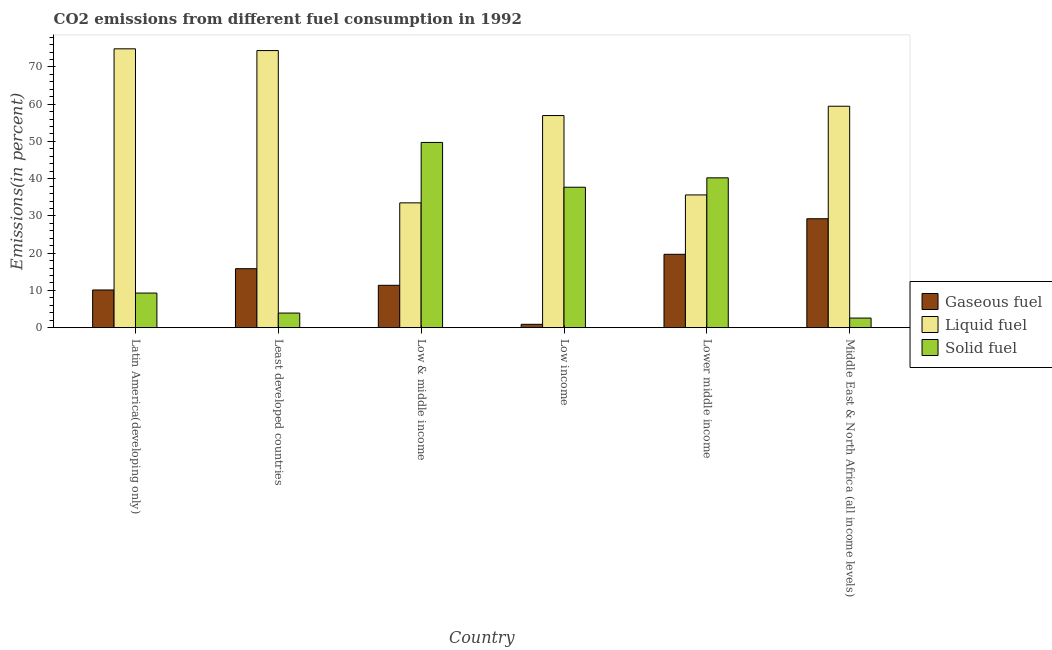Are the number of bars per tick equal to the number of legend labels?
Make the answer very short. Yes. How many bars are there on the 6th tick from the right?
Your answer should be very brief. 3. In how many cases, is the number of bars for a given country not equal to the number of legend labels?
Your answer should be very brief. 0. What is the percentage of gaseous fuel emission in Low & middle income?
Your answer should be compact. 11.37. Across all countries, what is the maximum percentage of liquid fuel emission?
Your response must be concise. 74.87. Across all countries, what is the minimum percentage of solid fuel emission?
Give a very brief answer. 2.57. In which country was the percentage of solid fuel emission minimum?
Provide a succinct answer. Middle East & North Africa (all income levels). What is the total percentage of liquid fuel emission in the graph?
Your answer should be compact. 334.81. What is the difference between the percentage of solid fuel emission in Low income and that in Middle East & North Africa (all income levels)?
Provide a short and direct response. 35.13. What is the difference between the percentage of liquid fuel emission in Lower middle income and the percentage of solid fuel emission in Least developed countries?
Offer a very short reply. 31.71. What is the average percentage of liquid fuel emission per country?
Provide a short and direct response. 55.8. What is the difference between the percentage of liquid fuel emission and percentage of gaseous fuel emission in Latin America(developing only)?
Offer a terse response. 64.75. What is the ratio of the percentage of gaseous fuel emission in Least developed countries to that in Low & middle income?
Provide a short and direct response. 1.39. Is the percentage of gaseous fuel emission in Low & middle income less than that in Middle East & North Africa (all income levels)?
Ensure brevity in your answer.  Yes. What is the difference between the highest and the second highest percentage of solid fuel emission?
Give a very brief answer. 9.5. What is the difference between the highest and the lowest percentage of gaseous fuel emission?
Your answer should be very brief. 28.34. What does the 2nd bar from the left in Low & middle income represents?
Make the answer very short. Liquid fuel. What does the 1st bar from the right in Low income represents?
Give a very brief answer. Solid fuel. Is it the case that in every country, the sum of the percentage of gaseous fuel emission and percentage of liquid fuel emission is greater than the percentage of solid fuel emission?
Offer a very short reply. No. How many bars are there?
Provide a succinct answer. 18. Are all the bars in the graph horizontal?
Keep it short and to the point. No. How many countries are there in the graph?
Provide a short and direct response. 6. Are the values on the major ticks of Y-axis written in scientific E-notation?
Ensure brevity in your answer.  No. Does the graph contain any zero values?
Make the answer very short. No. Does the graph contain grids?
Provide a succinct answer. No. Where does the legend appear in the graph?
Provide a short and direct response. Center right. How many legend labels are there?
Give a very brief answer. 3. What is the title of the graph?
Give a very brief answer. CO2 emissions from different fuel consumption in 1992. Does "Self-employed" appear as one of the legend labels in the graph?
Provide a short and direct response. No. What is the label or title of the Y-axis?
Your answer should be very brief. Emissions(in percent). What is the Emissions(in percent) of Gaseous fuel in Latin America(developing only)?
Your response must be concise. 10.12. What is the Emissions(in percent) in Liquid fuel in Latin America(developing only)?
Ensure brevity in your answer.  74.87. What is the Emissions(in percent) of Solid fuel in Latin America(developing only)?
Your response must be concise. 9.29. What is the Emissions(in percent) of Gaseous fuel in Least developed countries?
Provide a short and direct response. 15.83. What is the Emissions(in percent) of Liquid fuel in Least developed countries?
Give a very brief answer. 74.39. What is the Emissions(in percent) of Solid fuel in Least developed countries?
Offer a very short reply. 3.92. What is the Emissions(in percent) in Gaseous fuel in Low & middle income?
Keep it short and to the point. 11.37. What is the Emissions(in percent) in Liquid fuel in Low & middle income?
Keep it short and to the point. 33.51. What is the Emissions(in percent) in Solid fuel in Low & middle income?
Your response must be concise. 49.73. What is the Emissions(in percent) in Gaseous fuel in Low income?
Offer a terse response. 0.9. What is the Emissions(in percent) of Liquid fuel in Low income?
Your response must be concise. 56.95. What is the Emissions(in percent) in Solid fuel in Low income?
Your response must be concise. 37.7. What is the Emissions(in percent) of Gaseous fuel in Lower middle income?
Make the answer very short. 19.7. What is the Emissions(in percent) in Liquid fuel in Lower middle income?
Offer a terse response. 35.64. What is the Emissions(in percent) of Solid fuel in Lower middle income?
Your answer should be compact. 40.23. What is the Emissions(in percent) of Gaseous fuel in Middle East & North Africa (all income levels)?
Your answer should be very brief. 29.24. What is the Emissions(in percent) in Liquid fuel in Middle East & North Africa (all income levels)?
Your response must be concise. 59.45. What is the Emissions(in percent) in Solid fuel in Middle East & North Africa (all income levels)?
Ensure brevity in your answer.  2.57. Across all countries, what is the maximum Emissions(in percent) in Gaseous fuel?
Provide a succinct answer. 29.24. Across all countries, what is the maximum Emissions(in percent) of Liquid fuel?
Make the answer very short. 74.87. Across all countries, what is the maximum Emissions(in percent) in Solid fuel?
Ensure brevity in your answer.  49.73. Across all countries, what is the minimum Emissions(in percent) in Gaseous fuel?
Give a very brief answer. 0.9. Across all countries, what is the minimum Emissions(in percent) of Liquid fuel?
Your response must be concise. 33.51. Across all countries, what is the minimum Emissions(in percent) of Solid fuel?
Provide a succinct answer. 2.57. What is the total Emissions(in percent) in Gaseous fuel in the graph?
Ensure brevity in your answer.  87.16. What is the total Emissions(in percent) of Liquid fuel in the graph?
Your answer should be compact. 334.81. What is the total Emissions(in percent) in Solid fuel in the graph?
Offer a terse response. 143.45. What is the difference between the Emissions(in percent) in Gaseous fuel in Latin America(developing only) and that in Least developed countries?
Provide a succinct answer. -5.71. What is the difference between the Emissions(in percent) of Liquid fuel in Latin America(developing only) and that in Least developed countries?
Keep it short and to the point. 0.47. What is the difference between the Emissions(in percent) in Solid fuel in Latin America(developing only) and that in Least developed countries?
Your answer should be compact. 5.37. What is the difference between the Emissions(in percent) of Gaseous fuel in Latin America(developing only) and that in Low & middle income?
Offer a very short reply. -1.26. What is the difference between the Emissions(in percent) in Liquid fuel in Latin America(developing only) and that in Low & middle income?
Offer a terse response. 41.36. What is the difference between the Emissions(in percent) of Solid fuel in Latin America(developing only) and that in Low & middle income?
Give a very brief answer. -40.44. What is the difference between the Emissions(in percent) in Gaseous fuel in Latin America(developing only) and that in Low income?
Make the answer very short. 9.22. What is the difference between the Emissions(in percent) in Liquid fuel in Latin America(developing only) and that in Low income?
Your response must be concise. 17.92. What is the difference between the Emissions(in percent) in Solid fuel in Latin America(developing only) and that in Low income?
Offer a very short reply. -28.41. What is the difference between the Emissions(in percent) of Gaseous fuel in Latin America(developing only) and that in Lower middle income?
Your answer should be very brief. -9.58. What is the difference between the Emissions(in percent) of Liquid fuel in Latin America(developing only) and that in Lower middle income?
Ensure brevity in your answer.  39.23. What is the difference between the Emissions(in percent) in Solid fuel in Latin America(developing only) and that in Lower middle income?
Keep it short and to the point. -30.93. What is the difference between the Emissions(in percent) in Gaseous fuel in Latin America(developing only) and that in Middle East & North Africa (all income levels)?
Keep it short and to the point. -19.12. What is the difference between the Emissions(in percent) of Liquid fuel in Latin America(developing only) and that in Middle East & North Africa (all income levels)?
Provide a succinct answer. 15.41. What is the difference between the Emissions(in percent) in Solid fuel in Latin America(developing only) and that in Middle East & North Africa (all income levels)?
Ensure brevity in your answer.  6.72. What is the difference between the Emissions(in percent) in Gaseous fuel in Least developed countries and that in Low & middle income?
Keep it short and to the point. 4.46. What is the difference between the Emissions(in percent) in Liquid fuel in Least developed countries and that in Low & middle income?
Make the answer very short. 40.88. What is the difference between the Emissions(in percent) of Solid fuel in Least developed countries and that in Low & middle income?
Your answer should be compact. -45.81. What is the difference between the Emissions(in percent) in Gaseous fuel in Least developed countries and that in Low income?
Provide a short and direct response. 14.93. What is the difference between the Emissions(in percent) in Liquid fuel in Least developed countries and that in Low income?
Offer a very short reply. 17.45. What is the difference between the Emissions(in percent) in Solid fuel in Least developed countries and that in Low income?
Your answer should be very brief. -33.78. What is the difference between the Emissions(in percent) of Gaseous fuel in Least developed countries and that in Lower middle income?
Ensure brevity in your answer.  -3.87. What is the difference between the Emissions(in percent) of Liquid fuel in Least developed countries and that in Lower middle income?
Make the answer very short. 38.76. What is the difference between the Emissions(in percent) in Solid fuel in Least developed countries and that in Lower middle income?
Offer a terse response. -36.3. What is the difference between the Emissions(in percent) of Gaseous fuel in Least developed countries and that in Middle East & North Africa (all income levels)?
Offer a terse response. -13.41. What is the difference between the Emissions(in percent) in Liquid fuel in Least developed countries and that in Middle East & North Africa (all income levels)?
Ensure brevity in your answer.  14.94. What is the difference between the Emissions(in percent) of Solid fuel in Least developed countries and that in Middle East & North Africa (all income levels)?
Your answer should be very brief. 1.35. What is the difference between the Emissions(in percent) of Gaseous fuel in Low & middle income and that in Low income?
Your answer should be compact. 10.48. What is the difference between the Emissions(in percent) in Liquid fuel in Low & middle income and that in Low income?
Provide a short and direct response. -23.44. What is the difference between the Emissions(in percent) of Solid fuel in Low & middle income and that in Low income?
Provide a succinct answer. 12.03. What is the difference between the Emissions(in percent) of Gaseous fuel in Low & middle income and that in Lower middle income?
Ensure brevity in your answer.  -8.32. What is the difference between the Emissions(in percent) in Liquid fuel in Low & middle income and that in Lower middle income?
Your response must be concise. -2.13. What is the difference between the Emissions(in percent) in Solid fuel in Low & middle income and that in Lower middle income?
Provide a short and direct response. 9.5. What is the difference between the Emissions(in percent) in Gaseous fuel in Low & middle income and that in Middle East & North Africa (all income levels)?
Provide a short and direct response. -17.87. What is the difference between the Emissions(in percent) of Liquid fuel in Low & middle income and that in Middle East & North Africa (all income levels)?
Provide a succinct answer. -25.94. What is the difference between the Emissions(in percent) in Solid fuel in Low & middle income and that in Middle East & North Africa (all income levels)?
Make the answer very short. 47.15. What is the difference between the Emissions(in percent) of Gaseous fuel in Low income and that in Lower middle income?
Make the answer very short. -18.8. What is the difference between the Emissions(in percent) of Liquid fuel in Low income and that in Lower middle income?
Ensure brevity in your answer.  21.31. What is the difference between the Emissions(in percent) in Solid fuel in Low income and that in Lower middle income?
Your answer should be compact. -2.52. What is the difference between the Emissions(in percent) of Gaseous fuel in Low income and that in Middle East & North Africa (all income levels)?
Keep it short and to the point. -28.34. What is the difference between the Emissions(in percent) in Liquid fuel in Low income and that in Middle East & North Africa (all income levels)?
Offer a terse response. -2.51. What is the difference between the Emissions(in percent) of Solid fuel in Low income and that in Middle East & North Africa (all income levels)?
Give a very brief answer. 35.13. What is the difference between the Emissions(in percent) of Gaseous fuel in Lower middle income and that in Middle East & North Africa (all income levels)?
Make the answer very short. -9.54. What is the difference between the Emissions(in percent) of Liquid fuel in Lower middle income and that in Middle East & North Africa (all income levels)?
Provide a short and direct response. -23.82. What is the difference between the Emissions(in percent) of Solid fuel in Lower middle income and that in Middle East & North Africa (all income levels)?
Make the answer very short. 37.65. What is the difference between the Emissions(in percent) of Gaseous fuel in Latin America(developing only) and the Emissions(in percent) of Liquid fuel in Least developed countries?
Keep it short and to the point. -64.28. What is the difference between the Emissions(in percent) of Gaseous fuel in Latin America(developing only) and the Emissions(in percent) of Solid fuel in Least developed countries?
Provide a succinct answer. 6.19. What is the difference between the Emissions(in percent) in Liquid fuel in Latin America(developing only) and the Emissions(in percent) in Solid fuel in Least developed countries?
Your answer should be very brief. 70.94. What is the difference between the Emissions(in percent) in Gaseous fuel in Latin America(developing only) and the Emissions(in percent) in Liquid fuel in Low & middle income?
Ensure brevity in your answer.  -23.39. What is the difference between the Emissions(in percent) in Gaseous fuel in Latin America(developing only) and the Emissions(in percent) in Solid fuel in Low & middle income?
Your response must be concise. -39.61. What is the difference between the Emissions(in percent) of Liquid fuel in Latin America(developing only) and the Emissions(in percent) of Solid fuel in Low & middle income?
Provide a succinct answer. 25.14. What is the difference between the Emissions(in percent) in Gaseous fuel in Latin America(developing only) and the Emissions(in percent) in Liquid fuel in Low income?
Provide a short and direct response. -46.83. What is the difference between the Emissions(in percent) in Gaseous fuel in Latin America(developing only) and the Emissions(in percent) in Solid fuel in Low income?
Provide a short and direct response. -27.59. What is the difference between the Emissions(in percent) of Liquid fuel in Latin America(developing only) and the Emissions(in percent) of Solid fuel in Low income?
Give a very brief answer. 37.16. What is the difference between the Emissions(in percent) in Gaseous fuel in Latin America(developing only) and the Emissions(in percent) in Liquid fuel in Lower middle income?
Ensure brevity in your answer.  -25.52. What is the difference between the Emissions(in percent) of Gaseous fuel in Latin America(developing only) and the Emissions(in percent) of Solid fuel in Lower middle income?
Make the answer very short. -30.11. What is the difference between the Emissions(in percent) of Liquid fuel in Latin America(developing only) and the Emissions(in percent) of Solid fuel in Lower middle income?
Your answer should be very brief. 34.64. What is the difference between the Emissions(in percent) in Gaseous fuel in Latin America(developing only) and the Emissions(in percent) in Liquid fuel in Middle East & North Africa (all income levels)?
Ensure brevity in your answer.  -49.34. What is the difference between the Emissions(in percent) of Gaseous fuel in Latin America(developing only) and the Emissions(in percent) of Solid fuel in Middle East & North Africa (all income levels)?
Keep it short and to the point. 7.54. What is the difference between the Emissions(in percent) in Liquid fuel in Latin America(developing only) and the Emissions(in percent) in Solid fuel in Middle East & North Africa (all income levels)?
Your answer should be very brief. 72.29. What is the difference between the Emissions(in percent) of Gaseous fuel in Least developed countries and the Emissions(in percent) of Liquid fuel in Low & middle income?
Your answer should be compact. -17.68. What is the difference between the Emissions(in percent) in Gaseous fuel in Least developed countries and the Emissions(in percent) in Solid fuel in Low & middle income?
Your response must be concise. -33.9. What is the difference between the Emissions(in percent) of Liquid fuel in Least developed countries and the Emissions(in percent) of Solid fuel in Low & middle income?
Provide a short and direct response. 24.66. What is the difference between the Emissions(in percent) in Gaseous fuel in Least developed countries and the Emissions(in percent) in Liquid fuel in Low income?
Give a very brief answer. -41.12. What is the difference between the Emissions(in percent) of Gaseous fuel in Least developed countries and the Emissions(in percent) of Solid fuel in Low income?
Your response must be concise. -21.87. What is the difference between the Emissions(in percent) in Liquid fuel in Least developed countries and the Emissions(in percent) in Solid fuel in Low income?
Provide a short and direct response. 36.69. What is the difference between the Emissions(in percent) of Gaseous fuel in Least developed countries and the Emissions(in percent) of Liquid fuel in Lower middle income?
Your answer should be very brief. -19.81. What is the difference between the Emissions(in percent) in Gaseous fuel in Least developed countries and the Emissions(in percent) in Solid fuel in Lower middle income?
Keep it short and to the point. -24.39. What is the difference between the Emissions(in percent) of Liquid fuel in Least developed countries and the Emissions(in percent) of Solid fuel in Lower middle income?
Keep it short and to the point. 34.17. What is the difference between the Emissions(in percent) of Gaseous fuel in Least developed countries and the Emissions(in percent) of Liquid fuel in Middle East & North Africa (all income levels)?
Ensure brevity in your answer.  -43.62. What is the difference between the Emissions(in percent) of Gaseous fuel in Least developed countries and the Emissions(in percent) of Solid fuel in Middle East & North Africa (all income levels)?
Offer a terse response. 13.26. What is the difference between the Emissions(in percent) of Liquid fuel in Least developed countries and the Emissions(in percent) of Solid fuel in Middle East & North Africa (all income levels)?
Provide a short and direct response. 71.82. What is the difference between the Emissions(in percent) of Gaseous fuel in Low & middle income and the Emissions(in percent) of Liquid fuel in Low income?
Your answer should be compact. -45.57. What is the difference between the Emissions(in percent) in Gaseous fuel in Low & middle income and the Emissions(in percent) in Solid fuel in Low income?
Offer a very short reply. -26.33. What is the difference between the Emissions(in percent) of Liquid fuel in Low & middle income and the Emissions(in percent) of Solid fuel in Low income?
Offer a very short reply. -4.19. What is the difference between the Emissions(in percent) in Gaseous fuel in Low & middle income and the Emissions(in percent) in Liquid fuel in Lower middle income?
Give a very brief answer. -24.26. What is the difference between the Emissions(in percent) in Gaseous fuel in Low & middle income and the Emissions(in percent) in Solid fuel in Lower middle income?
Offer a very short reply. -28.85. What is the difference between the Emissions(in percent) of Liquid fuel in Low & middle income and the Emissions(in percent) of Solid fuel in Lower middle income?
Keep it short and to the point. -6.71. What is the difference between the Emissions(in percent) in Gaseous fuel in Low & middle income and the Emissions(in percent) in Liquid fuel in Middle East & North Africa (all income levels)?
Your response must be concise. -48.08. What is the difference between the Emissions(in percent) in Gaseous fuel in Low & middle income and the Emissions(in percent) in Solid fuel in Middle East & North Africa (all income levels)?
Your answer should be compact. 8.8. What is the difference between the Emissions(in percent) of Liquid fuel in Low & middle income and the Emissions(in percent) of Solid fuel in Middle East & North Africa (all income levels)?
Your answer should be very brief. 30.94. What is the difference between the Emissions(in percent) in Gaseous fuel in Low income and the Emissions(in percent) in Liquid fuel in Lower middle income?
Offer a very short reply. -34.74. What is the difference between the Emissions(in percent) of Gaseous fuel in Low income and the Emissions(in percent) of Solid fuel in Lower middle income?
Offer a terse response. -39.33. What is the difference between the Emissions(in percent) in Liquid fuel in Low income and the Emissions(in percent) in Solid fuel in Lower middle income?
Give a very brief answer. 16.72. What is the difference between the Emissions(in percent) in Gaseous fuel in Low income and the Emissions(in percent) in Liquid fuel in Middle East & North Africa (all income levels)?
Provide a short and direct response. -58.56. What is the difference between the Emissions(in percent) in Gaseous fuel in Low income and the Emissions(in percent) in Solid fuel in Middle East & North Africa (all income levels)?
Provide a short and direct response. -1.68. What is the difference between the Emissions(in percent) of Liquid fuel in Low income and the Emissions(in percent) of Solid fuel in Middle East & North Africa (all income levels)?
Offer a terse response. 54.37. What is the difference between the Emissions(in percent) of Gaseous fuel in Lower middle income and the Emissions(in percent) of Liquid fuel in Middle East & North Africa (all income levels)?
Provide a short and direct response. -39.76. What is the difference between the Emissions(in percent) of Gaseous fuel in Lower middle income and the Emissions(in percent) of Solid fuel in Middle East & North Africa (all income levels)?
Make the answer very short. 17.12. What is the difference between the Emissions(in percent) in Liquid fuel in Lower middle income and the Emissions(in percent) in Solid fuel in Middle East & North Africa (all income levels)?
Keep it short and to the point. 33.06. What is the average Emissions(in percent) in Gaseous fuel per country?
Keep it short and to the point. 14.53. What is the average Emissions(in percent) of Liquid fuel per country?
Make the answer very short. 55.8. What is the average Emissions(in percent) of Solid fuel per country?
Give a very brief answer. 23.91. What is the difference between the Emissions(in percent) in Gaseous fuel and Emissions(in percent) in Liquid fuel in Latin America(developing only)?
Provide a succinct answer. -64.75. What is the difference between the Emissions(in percent) in Gaseous fuel and Emissions(in percent) in Solid fuel in Latin America(developing only)?
Give a very brief answer. 0.83. What is the difference between the Emissions(in percent) of Liquid fuel and Emissions(in percent) of Solid fuel in Latin America(developing only)?
Your answer should be very brief. 65.58. What is the difference between the Emissions(in percent) in Gaseous fuel and Emissions(in percent) in Liquid fuel in Least developed countries?
Ensure brevity in your answer.  -58.56. What is the difference between the Emissions(in percent) of Gaseous fuel and Emissions(in percent) of Solid fuel in Least developed countries?
Offer a very short reply. 11.91. What is the difference between the Emissions(in percent) of Liquid fuel and Emissions(in percent) of Solid fuel in Least developed countries?
Keep it short and to the point. 70.47. What is the difference between the Emissions(in percent) in Gaseous fuel and Emissions(in percent) in Liquid fuel in Low & middle income?
Provide a short and direct response. -22.14. What is the difference between the Emissions(in percent) in Gaseous fuel and Emissions(in percent) in Solid fuel in Low & middle income?
Offer a very short reply. -38.36. What is the difference between the Emissions(in percent) in Liquid fuel and Emissions(in percent) in Solid fuel in Low & middle income?
Offer a very short reply. -16.22. What is the difference between the Emissions(in percent) of Gaseous fuel and Emissions(in percent) of Liquid fuel in Low income?
Make the answer very short. -56.05. What is the difference between the Emissions(in percent) in Gaseous fuel and Emissions(in percent) in Solid fuel in Low income?
Keep it short and to the point. -36.81. What is the difference between the Emissions(in percent) in Liquid fuel and Emissions(in percent) in Solid fuel in Low income?
Provide a succinct answer. 19.24. What is the difference between the Emissions(in percent) of Gaseous fuel and Emissions(in percent) of Liquid fuel in Lower middle income?
Your answer should be compact. -15.94. What is the difference between the Emissions(in percent) in Gaseous fuel and Emissions(in percent) in Solid fuel in Lower middle income?
Provide a succinct answer. -20.53. What is the difference between the Emissions(in percent) of Liquid fuel and Emissions(in percent) of Solid fuel in Lower middle income?
Provide a short and direct response. -4.59. What is the difference between the Emissions(in percent) of Gaseous fuel and Emissions(in percent) of Liquid fuel in Middle East & North Africa (all income levels)?
Offer a very short reply. -30.21. What is the difference between the Emissions(in percent) in Gaseous fuel and Emissions(in percent) in Solid fuel in Middle East & North Africa (all income levels)?
Ensure brevity in your answer.  26.67. What is the difference between the Emissions(in percent) in Liquid fuel and Emissions(in percent) in Solid fuel in Middle East & North Africa (all income levels)?
Your response must be concise. 56.88. What is the ratio of the Emissions(in percent) in Gaseous fuel in Latin America(developing only) to that in Least developed countries?
Keep it short and to the point. 0.64. What is the ratio of the Emissions(in percent) in Solid fuel in Latin America(developing only) to that in Least developed countries?
Give a very brief answer. 2.37. What is the ratio of the Emissions(in percent) of Gaseous fuel in Latin America(developing only) to that in Low & middle income?
Keep it short and to the point. 0.89. What is the ratio of the Emissions(in percent) in Liquid fuel in Latin America(developing only) to that in Low & middle income?
Your response must be concise. 2.23. What is the ratio of the Emissions(in percent) in Solid fuel in Latin America(developing only) to that in Low & middle income?
Your response must be concise. 0.19. What is the ratio of the Emissions(in percent) in Gaseous fuel in Latin America(developing only) to that in Low income?
Provide a short and direct response. 11.27. What is the ratio of the Emissions(in percent) of Liquid fuel in Latin America(developing only) to that in Low income?
Your response must be concise. 1.31. What is the ratio of the Emissions(in percent) in Solid fuel in Latin America(developing only) to that in Low income?
Offer a very short reply. 0.25. What is the ratio of the Emissions(in percent) in Gaseous fuel in Latin America(developing only) to that in Lower middle income?
Offer a very short reply. 0.51. What is the ratio of the Emissions(in percent) of Liquid fuel in Latin America(developing only) to that in Lower middle income?
Make the answer very short. 2.1. What is the ratio of the Emissions(in percent) of Solid fuel in Latin America(developing only) to that in Lower middle income?
Your answer should be very brief. 0.23. What is the ratio of the Emissions(in percent) of Gaseous fuel in Latin America(developing only) to that in Middle East & North Africa (all income levels)?
Offer a terse response. 0.35. What is the ratio of the Emissions(in percent) of Liquid fuel in Latin America(developing only) to that in Middle East & North Africa (all income levels)?
Keep it short and to the point. 1.26. What is the ratio of the Emissions(in percent) in Solid fuel in Latin America(developing only) to that in Middle East & North Africa (all income levels)?
Your answer should be compact. 3.61. What is the ratio of the Emissions(in percent) in Gaseous fuel in Least developed countries to that in Low & middle income?
Ensure brevity in your answer.  1.39. What is the ratio of the Emissions(in percent) in Liquid fuel in Least developed countries to that in Low & middle income?
Provide a short and direct response. 2.22. What is the ratio of the Emissions(in percent) in Solid fuel in Least developed countries to that in Low & middle income?
Your answer should be very brief. 0.08. What is the ratio of the Emissions(in percent) in Gaseous fuel in Least developed countries to that in Low income?
Your answer should be compact. 17.63. What is the ratio of the Emissions(in percent) in Liquid fuel in Least developed countries to that in Low income?
Offer a terse response. 1.31. What is the ratio of the Emissions(in percent) of Solid fuel in Least developed countries to that in Low income?
Offer a terse response. 0.1. What is the ratio of the Emissions(in percent) in Gaseous fuel in Least developed countries to that in Lower middle income?
Your answer should be very brief. 0.8. What is the ratio of the Emissions(in percent) of Liquid fuel in Least developed countries to that in Lower middle income?
Keep it short and to the point. 2.09. What is the ratio of the Emissions(in percent) in Solid fuel in Least developed countries to that in Lower middle income?
Your answer should be very brief. 0.1. What is the ratio of the Emissions(in percent) in Gaseous fuel in Least developed countries to that in Middle East & North Africa (all income levels)?
Give a very brief answer. 0.54. What is the ratio of the Emissions(in percent) of Liquid fuel in Least developed countries to that in Middle East & North Africa (all income levels)?
Offer a very short reply. 1.25. What is the ratio of the Emissions(in percent) of Solid fuel in Least developed countries to that in Middle East & North Africa (all income levels)?
Provide a short and direct response. 1.52. What is the ratio of the Emissions(in percent) of Gaseous fuel in Low & middle income to that in Low income?
Keep it short and to the point. 12.67. What is the ratio of the Emissions(in percent) in Liquid fuel in Low & middle income to that in Low income?
Keep it short and to the point. 0.59. What is the ratio of the Emissions(in percent) of Solid fuel in Low & middle income to that in Low income?
Keep it short and to the point. 1.32. What is the ratio of the Emissions(in percent) in Gaseous fuel in Low & middle income to that in Lower middle income?
Your answer should be compact. 0.58. What is the ratio of the Emissions(in percent) in Liquid fuel in Low & middle income to that in Lower middle income?
Keep it short and to the point. 0.94. What is the ratio of the Emissions(in percent) in Solid fuel in Low & middle income to that in Lower middle income?
Offer a very short reply. 1.24. What is the ratio of the Emissions(in percent) in Gaseous fuel in Low & middle income to that in Middle East & North Africa (all income levels)?
Your answer should be compact. 0.39. What is the ratio of the Emissions(in percent) of Liquid fuel in Low & middle income to that in Middle East & North Africa (all income levels)?
Your answer should be compact. 0.56. What is the ratio of the Emissions(in percent) in Solid fuel in Low & middle income to that in Middle East & North Africa (all income levels)?
Your answer should be compact. 19.32. What is the ratio of the Emissions(in percent) in Gaseous fuel in Low income to that in Lower middle income?
Your response must be concise. 0.05. What is the ratio of the Emissions(in percent) in Liquid fuel in Low income to that in Lower middle income?
Offer a terse response. 1.6. What is the ratio of the Emissions(in percent) in Solid fuel in Low income to that in Lower middle income?
Offer a terse response. 0.94. What is the ratio of the Emissions(in percent) in Gaseous fuel in Low income to that in Middle East & North Africa (all income levels)?
Your answer should be compact. 0.03. What is the ratio of the Emissions(in percent) of Liquid fuel in Low income to that in Middle East & North Africa (all income levels)?
Ensure brevity in your answer.  0.96. What is the ratio of the Emissions(in percent) of Solid fuel in Low income to that in Middle East & North Africa (all income levels)?
Keep it short and to the point. 14.64. What is the ratio of the Emissions(in percent) of Gaseous fuel in Lower middle income to that in Middle East & North Africa (all income levels)?
Provide a succinct answer. 0.67. What is the ratio of the Emissions(in percent) of Liquid fuel in Lower middle income to that in Middle East & North Africa (all income levels)?
Your response must be concise. 0.6. What is the ratio of the Emissions(in percent) of Solid fuel in Lower middle income to that in Middle East & North Africa (all income levels)?
Provide a succinct answer. 15.62. What is the difference between the highest and the second highest Emissions(in percent) of Gaseous fuel?
Give a very brief answer. 9.54. What is the difference between the highest and the second highest Emissions(in percent) of Liquid fuel?
Make the answer very short. 0.47. What is the difference between the highest and the second highest Emissions(in percent) in Solid fuel?
Your answer should be very brief. 9.5. What is the difference between the highest and the lowest Emissions(in percent) in Gaseous fuel?
Provide a short and direct response. 28.34. What is the difference between the highest and the lowest Emissions(in percent) of Liquid fuel?
Keep it short and to the point. 41.36. What is the difference between the highest and the lowest Emissions(in percent) in Solid fuel?
Provide a short and direct response. 47.15. 